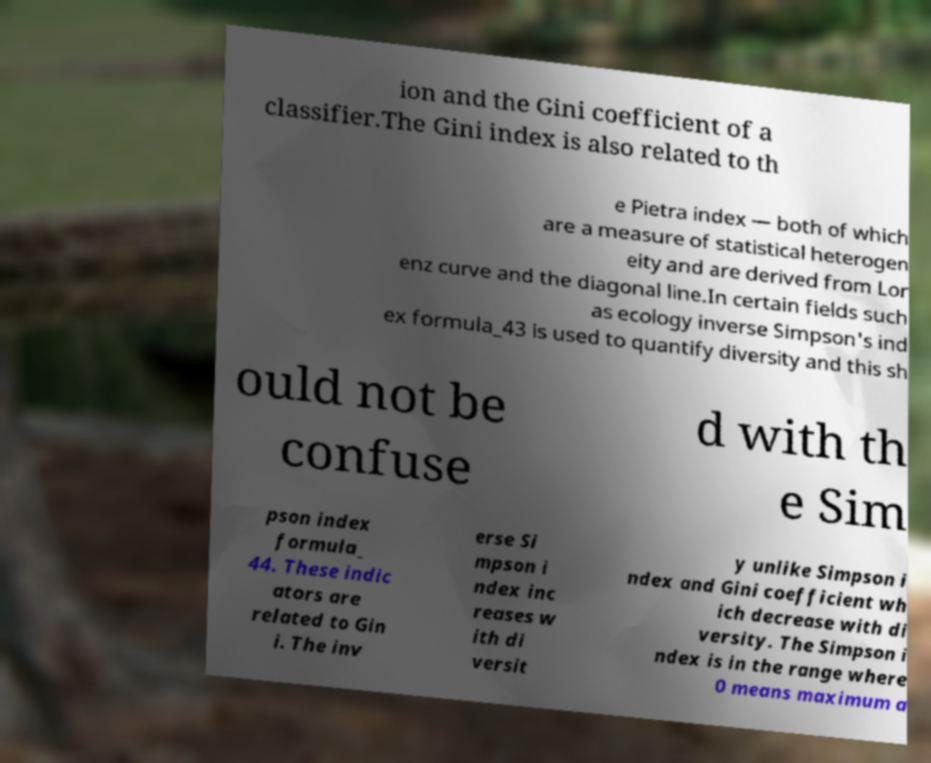Please read and relay the text visible in this image. What does it say? ion and the Gini coefficient of a classifier.The Gini index is also related to th e Pietra index — both of which are a measure of statistical heterogen eity and are derived from Lor enz curve and the diagonal line.In certain fields such as ecology inverse Simpson's ind ex formula_43 is used to quantify diversity and this sh ould not be confuse d with th e Sim pson index formula_ 44. These indic ators are related to Gin i. The inv erse Si mpson i ndex inc reases w ith di versit y unlike Simpson i ndex and Gini coefficient wh ich decrease with di versity. The Simpson i ndex is in the range where 0 means maximum a 